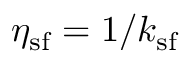<formula> <loc_0><loc_0><loc_500><loc_500>\eta _ { s f } = 1 / k _ { s f }</formula> 